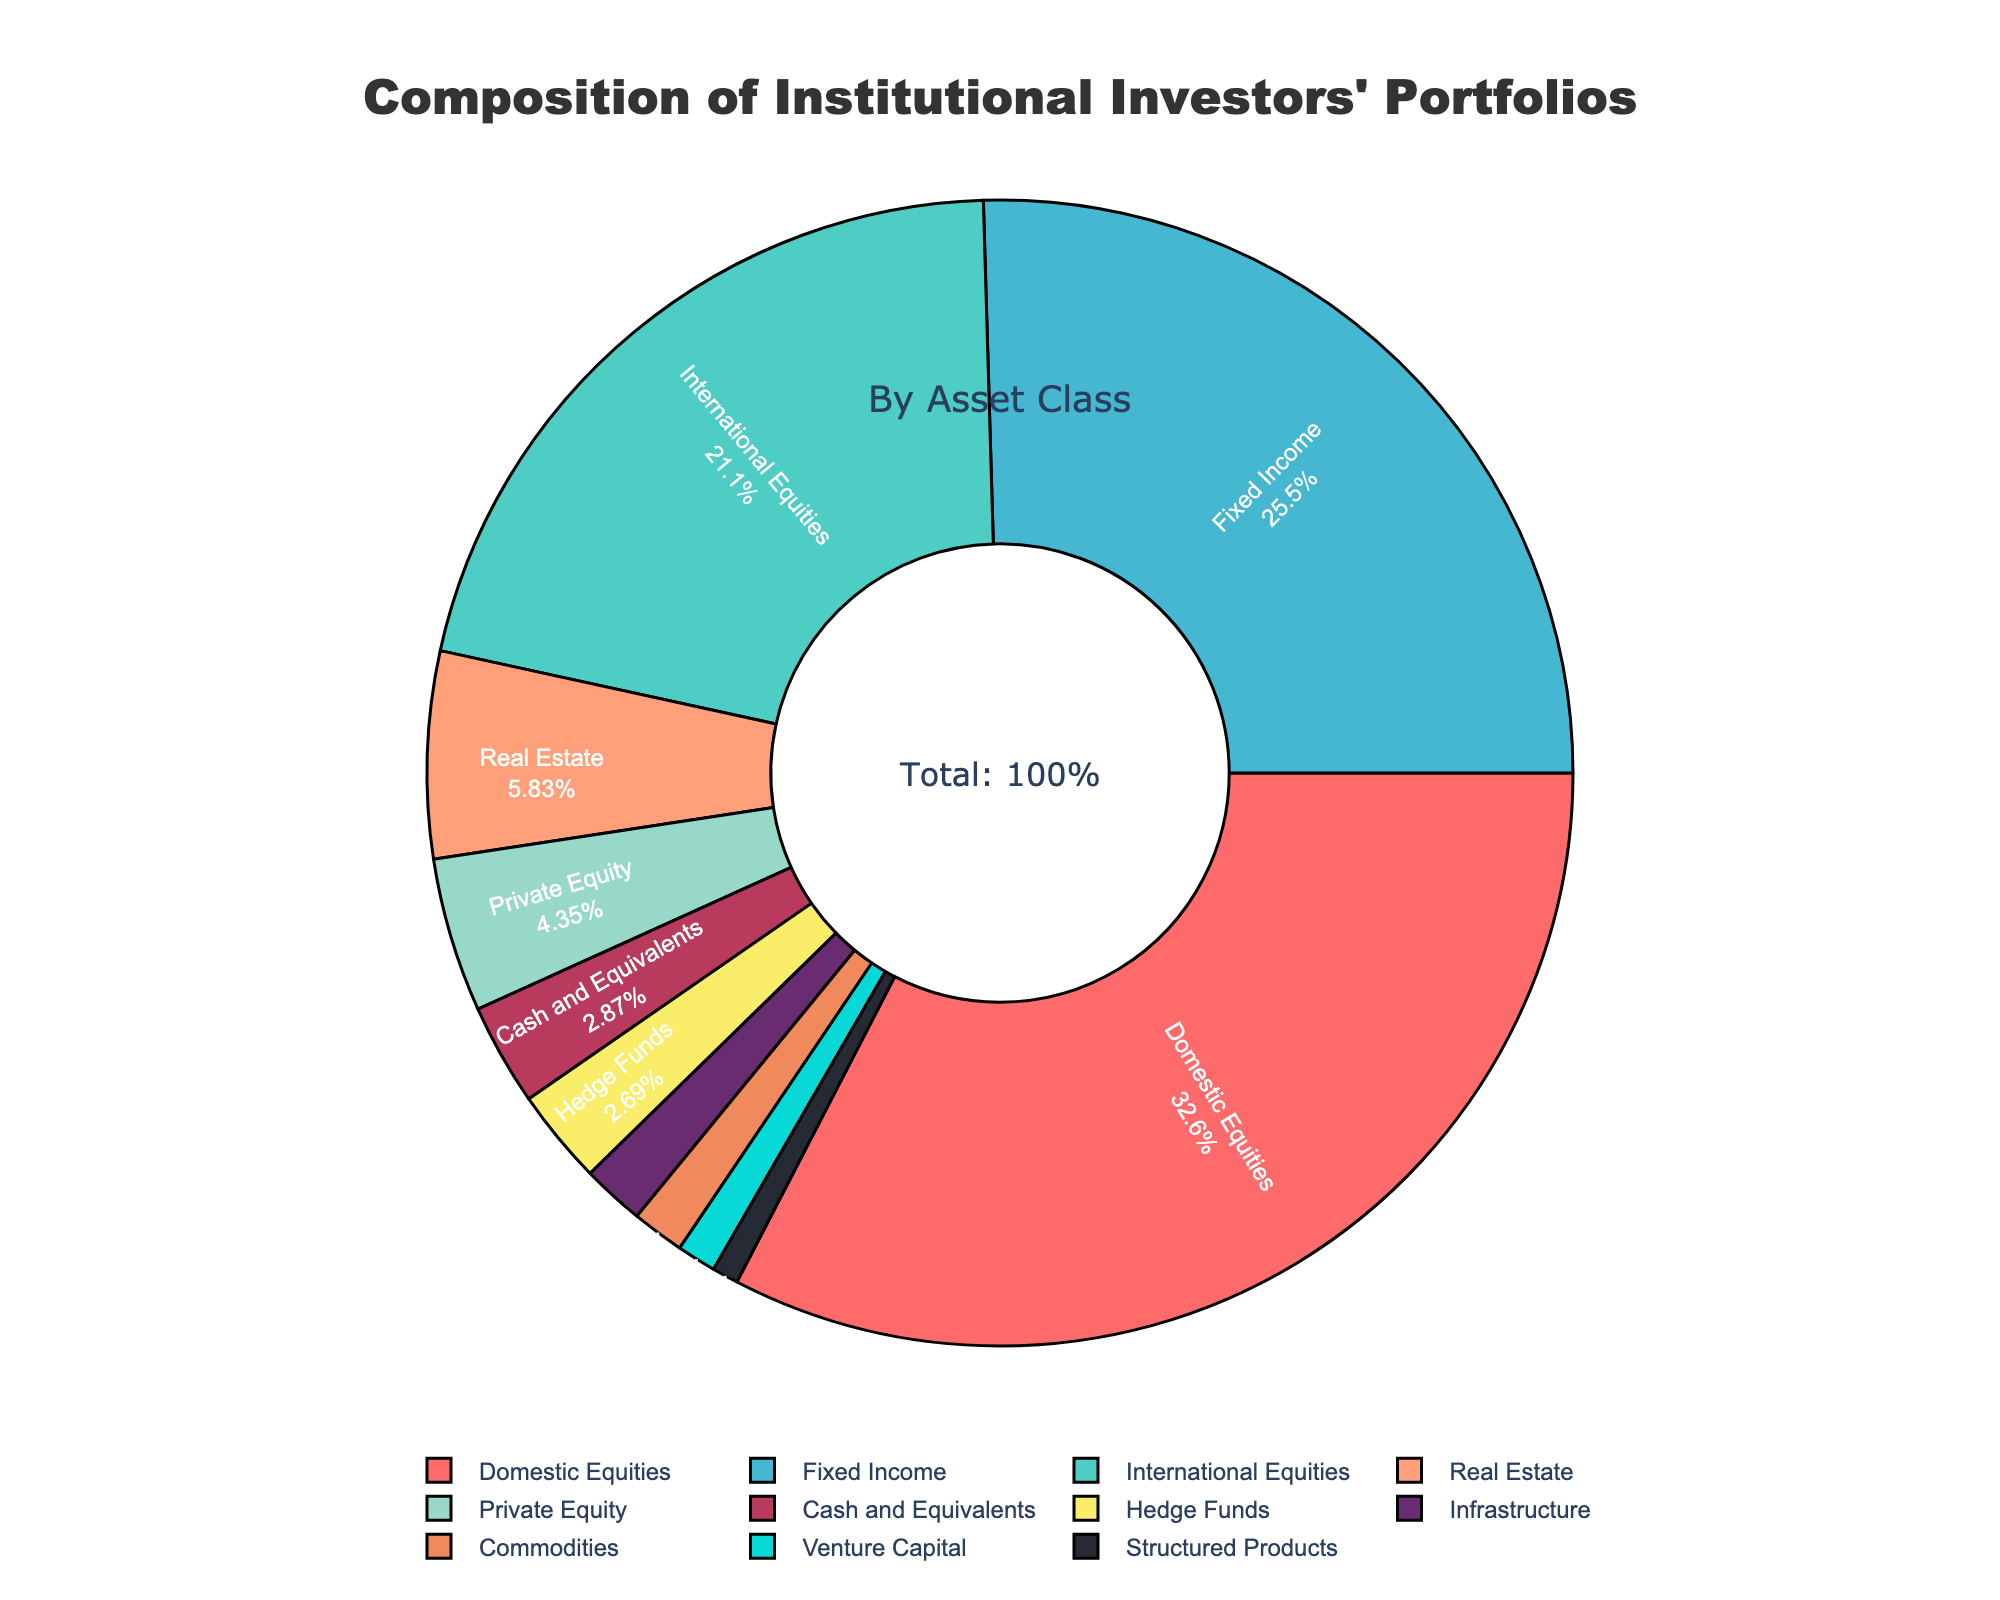Which asset class has the highest percentage in the institutional investors' portfolios? The slice representing "Domestic Equities" is the largest, indicating it has the highest percentage.
Answer: Domestic Equities Which asset class has a larger percentage, International Equities or Fixed Income? The slices for International Equities and Fixed Income can be compared by their sizes. Fixed Income is larger than International Equities.
Answer: Fixed Income What is the combined percentage of Real Estate, Private Equity, and Hedge Funds? Adding the percentages of Real Estate (6.3%), Private Equity (4.7%), and Hedge Funds (2.9%) gives 6.3 + 4.7 + 2.9 = 13.9%.
Answer: 13.9% How much larger is the percentage for Domestic Equities compared to International Equities? Subtracting the percentage of International Equities (22.8%) from Domestic Equities (35.2%) gives 35.2 - 22.8 = 12.4%.
Answer: 12.4% Which asset class is represented by the smallest slice, and what percentage does it have? The smallest slice corresponds to Structured Products, which has a percentage of 0.8%.
Answer: Structured Products, 0.8% What is the difference between the total percentage of equites (Domestic + International) and Fixed Income? Summing Domestic Equities (35.2%) and International Equities (22.8%) gives 35.2 + 22.8 = 58%. Subtracting Fixed Income's percentage (27.5%) from this sum gives 58 - 27.5 = 30.5%.
Answer: 30.5% Is the percentage of Cash and Equivalents higher or lower than that of Real Estate? Comparing the two slices, Cash and Equivalents (3.1%) is lower than Real Estate (6.3%).
Answer: Lower What is the total percentage for all asset classes less than 5%? Summing the percentages of asset classes less than 5% (Private Equity 4.7%, Hedge Funds 2.9%, Commodities 1.6%, Cash and Equivalents 3.1%, Infrastructure 1.9%, Venture Capital 1.2%, Structured Products 0.8%) gives 4.7 + 2.9 + 1.6 + 3.1 + 1.9 + 1.2 + 0.8 = 16.2%.
Answer: 16.2% Which asset class has a higher percentage, Commodities or Venture Capital? Comparing the slices, Commodities (1.6%) has a higher percentage than Venture Capital (1.2%).
Answer: Commodities What is the average percentage of Hedge Funds, Commodities, and Infrastructure? Adding the percentages of Hedge Funds (2.9%), Commodities (1.6%), and Infrastructure (1.9%) gives 2.9 + 1.6 + 1.9 = 6.4%. Dividing by 3 for the average, 6.4 / 3 gives approximately 2.13%.
Answer: 2.13% 